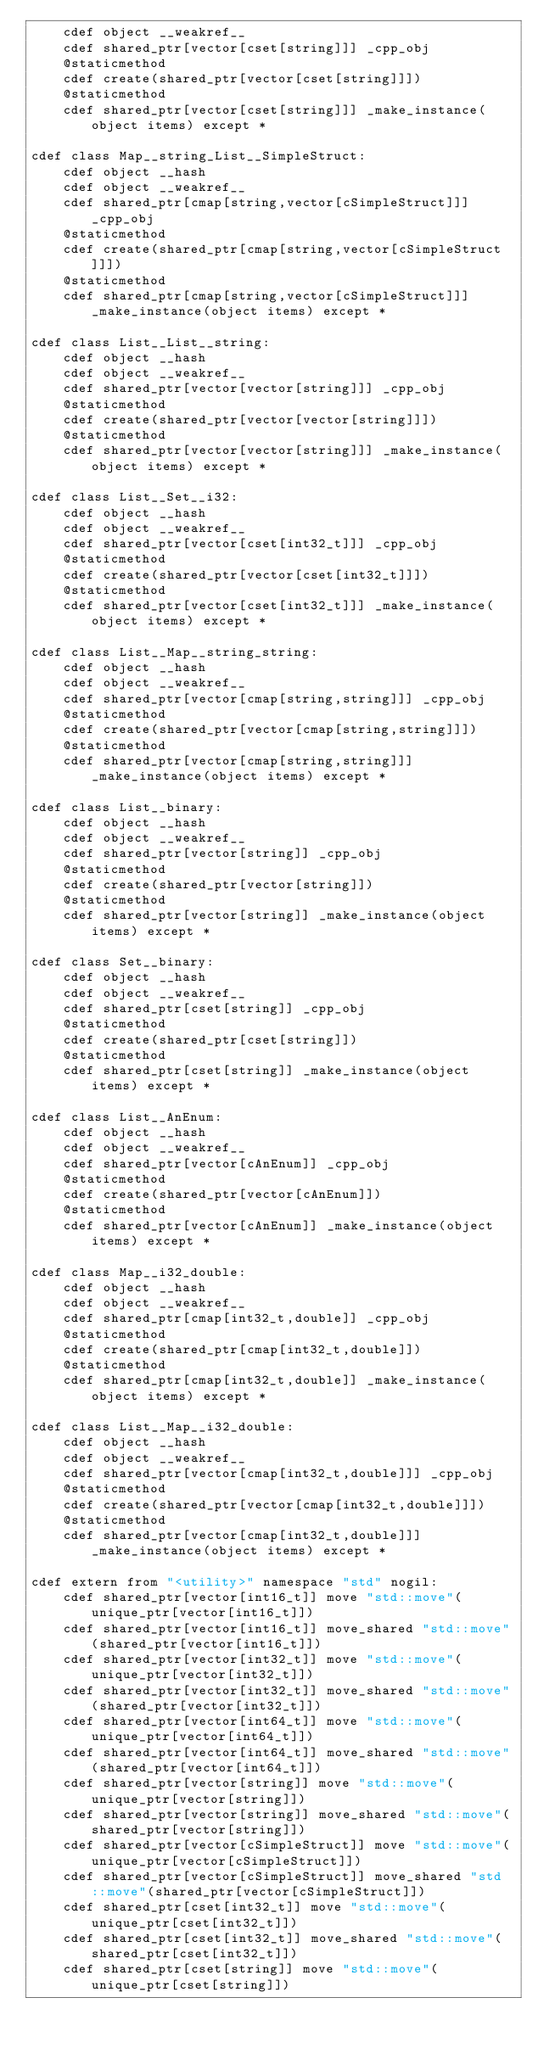<code> <loc_0><loc_0><loc_500><loc_500><_Cython_>    cdef object __weakref__
    cdef shared_ptr[vector[cset[string]]] _cpp_obj
    @staticmethod
    cdef create(shared_ptr[vector[cset[string]]])
    @staticmethod
    cdef shared_ptr[vector[cset[string]]] _make_instance(object items) except *

cdef class Map__string_List__SimpleStruct:
    cdef object __hash
    cdef object __weakref__
    cdef shared_ptr[cmap[string,vector[cSimpleStruct]]] _cpp_obj
    @staticmethod
    cdef create(shared_ptr[cmap[string,vector[cSimpleStruct]]])
    @staticmethod
    cdef shared_ptr[cmap[string,vector[cSimpleStruct]]] _make_instance(object items) except *

cdef class List__List__string:
    cdef object __hash
    cdef object __weakref__
    cdef shared_ptr[vector[vector[string]]] _cpp_obj
    @staticmethod
    cdef create(shared_ptr[vector[vector[string]]])
    @staticmethod
    cdef shared_ptr[vector[vector[string]]] _make_instance(object items) except *

cdef class List__Set__i32:
    cdef object __hash
    cdef object __weakref__
    cdef shared_ptr[vector[cset[int32_t]]] _cpp_obj
    @staticmethod
    cdef create(shared_ptr[vector[cset[int32_t]]])
    @staticmethod
    cdef shared_ptr[vector[cset[int32_t]]] _make_instance(object items) except *

cdef class List__Map__string_string:
    cdef object __hash
    cdef object __weakref__
    cdef shared_ptr[vector[cmap[string,string]]] _cpp_obj
    @staticmethod
    cdef create(shared_ptr[vector[cmap[string,string]]])
    @staticmethod
    cdef shared_ptr[vector[cmap[string,string]]] _make_instance(object items) except *

cdef class List__binary:
    cdef object __hash
    cdef object __weakref__
    cdef shared_ptr[vector[string]] _cpp_obj
    @staticmethod
    cdef create(shared_ptr[vector[string]])
    @staticmethod
    cdef shared_ptr[vector[string]] _make_instance(object items) except *

cdef class Set__binary:
    cdef object __hash
    cdef object __weakref__
    cdef shared_ptr[cset[string]] _cpp_obj
    @staticmethod
    cdef create(shared_ptr[cset[string]])
    @staticmethod
    cdef shared_ptr[cset[string]] _make_instance(object items) except *

cdef class List__AnEnum:
    cdef object __hash
    cdef object __weakref__
    cdef shared_ptr[vector[cAnEnum]] _cpp_obj
    @staticmethod
    cdef create(shared_ptr[vector[cAnEnum]])
    @staticmethod
    cdef shared_ptr[vector[cAnEnum]] _make_instance(object items) except *

cdef class Map__i32_double:
    cdef object __hash
    cdef object __weakref__
    cdef shared_ptr[cmap[int32_t,double]] _cpp_obj
    @staticmethod
    cdef create(shared_ptr[cmap[int32_t,double]])
    @staticmethod
    cdef shared_ptr[cmap[int32_t,double]] _make_instance(object items) except *

cdef class List__Map__i32_double:
    cdef object __hash
    cdef object __weakref__
    cdef shared_ptr[vector[cmap[int32_t,double]]] _cpp_obj
    @staticmethod
    cdef create(shared_ptr[vector[cmap[int32_t,double]]])
    @staticmethod
    cdef shared_ptr[vector[cmap[int32_t,double]]] _make_instance(object items) except *

cdef extern from "<utility>" namespace "std" nogil:
    cdef shared_ptr[vector[int16_t]] move "std::move"(unique_ptr[vector[int16_t]])
    cdef shared_ptr[vector[int16_t]] move_shared "std::move"(shared_ptr[vector[int16_t]])
    cdef shared_ptr[vector[int32_t]] move "std::move"(unique_ptr[vector[int32_t]])
    cdef shared_ptr[vector[int32_t]] move_shared "std::move"(shared_ptr[vector[int32_t]])
    cdef shared_ptr[vector[int64_t]] move "std::move"(unique_ptr[vector[int64_t]])
    cdef shared_ptr[vector[int64_t]] move_shared "std::move"(shared_ptr[vector[int64_t]])
    cdef shared_ptr[vector[string]] move "std::move"(unique_ptr[vector[string]])
    cdef shared_ptr[vector[string]] move_shared "std::move"(shared_ptr[vector[string]])
    cdef shared_ptr[vector[cSimpleStruct]] move "std::move"(unique_ptr[vector[cSimpleStruct]])
    cdef shared_ptr[vector[cSimpleStruct]] move_shared "std::move"(shared_ptr[vector[cSimpleStruct]])
    cdef shared_ptr[cset[int32_t]] move "std::move"(unique_ptr[cset[int32_t]])
    cdef shared_ptr[cset[int32_t]] move_shared "std::move"(shared_ptr[cset[int32_t]])
    cdef shared_ptr[cset[string]] move "std::move"(unique_ptr[cset[string]])</code> 